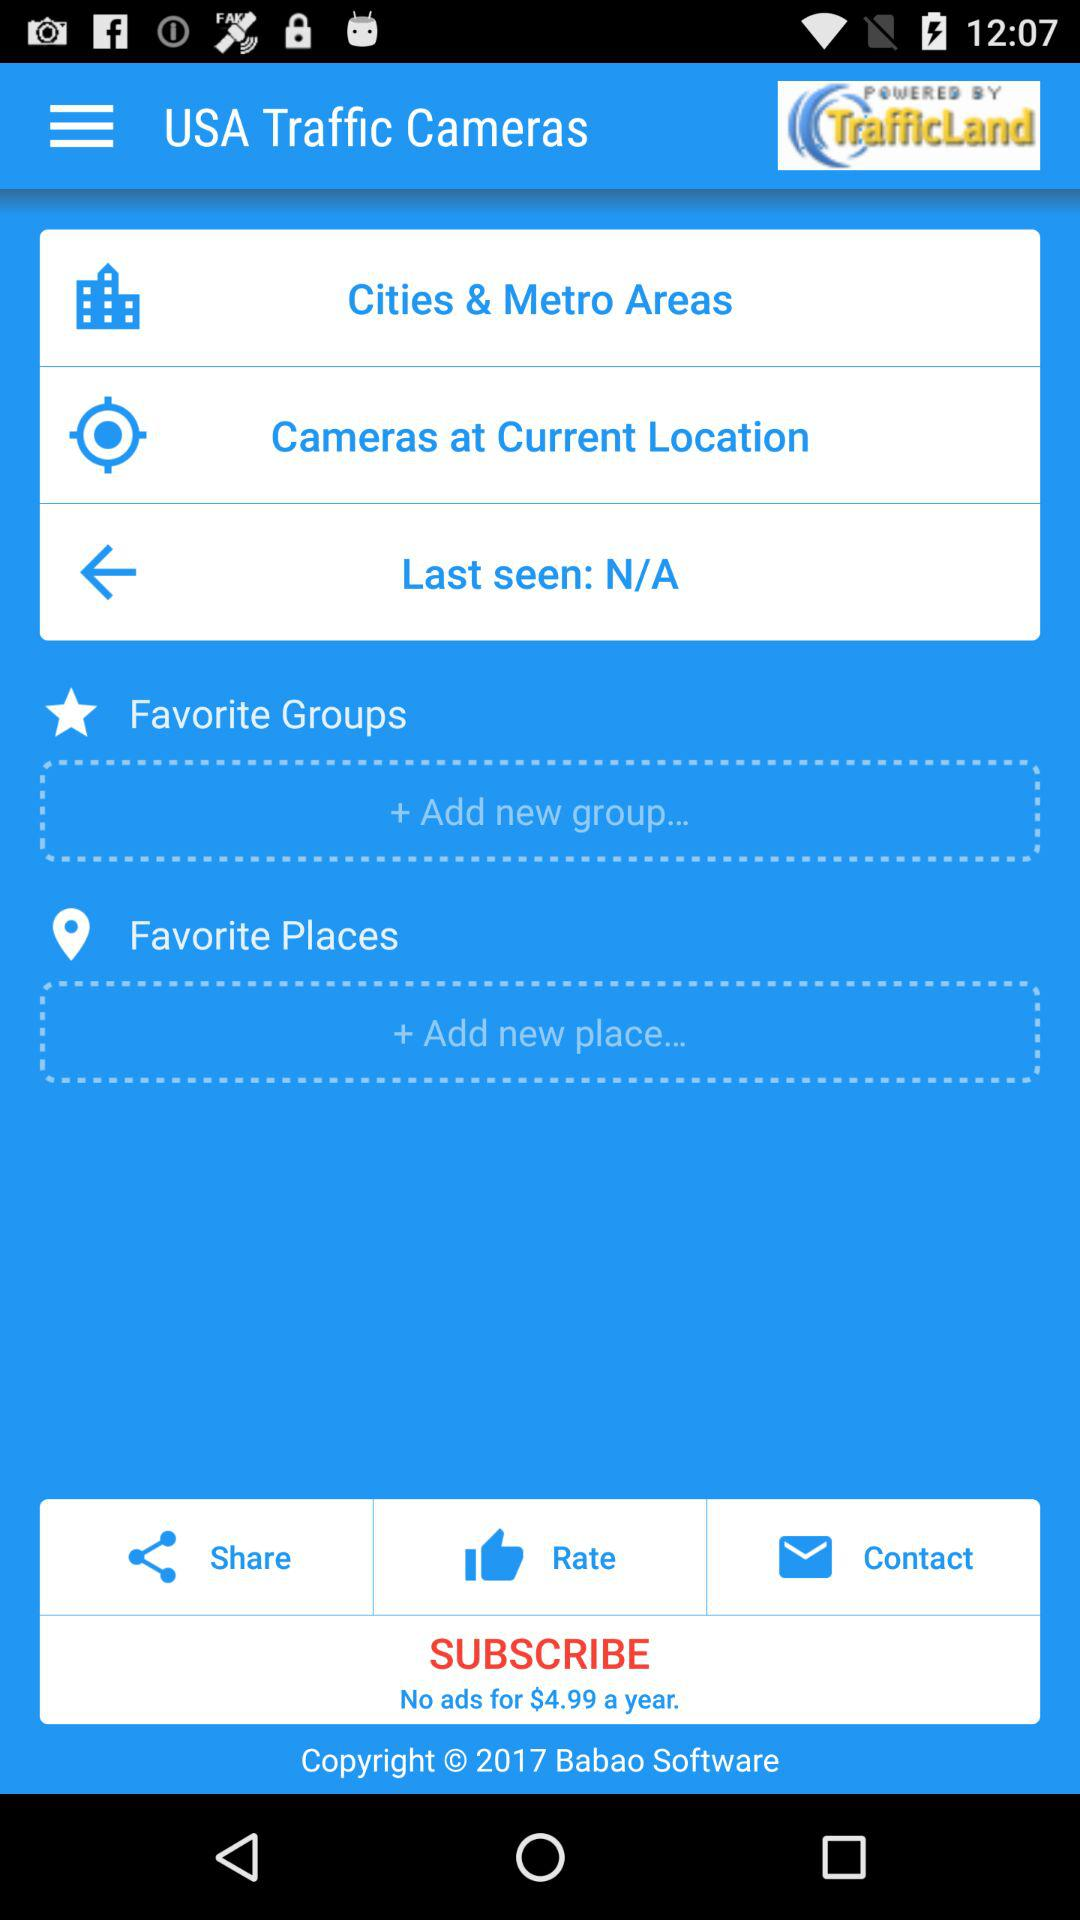With which applications can this be shared?
When the provided information is insufficient, respond with <no answer>. <no answer> 